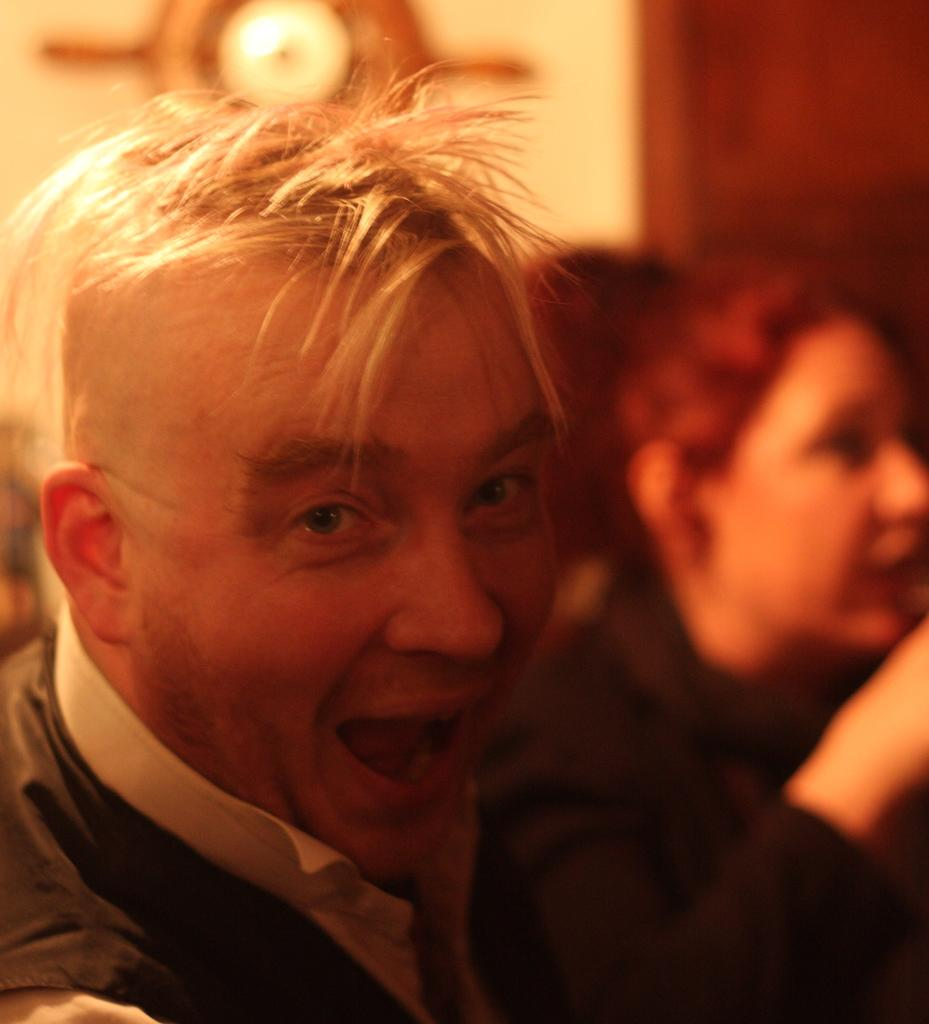Who is the main subject in the image? There is a man in the image. Can you describe the background of the image? The background of the image is blurred. What type of board is the man using to weigh himself in the image? There is no board or any weighing activity depicted in the image. 